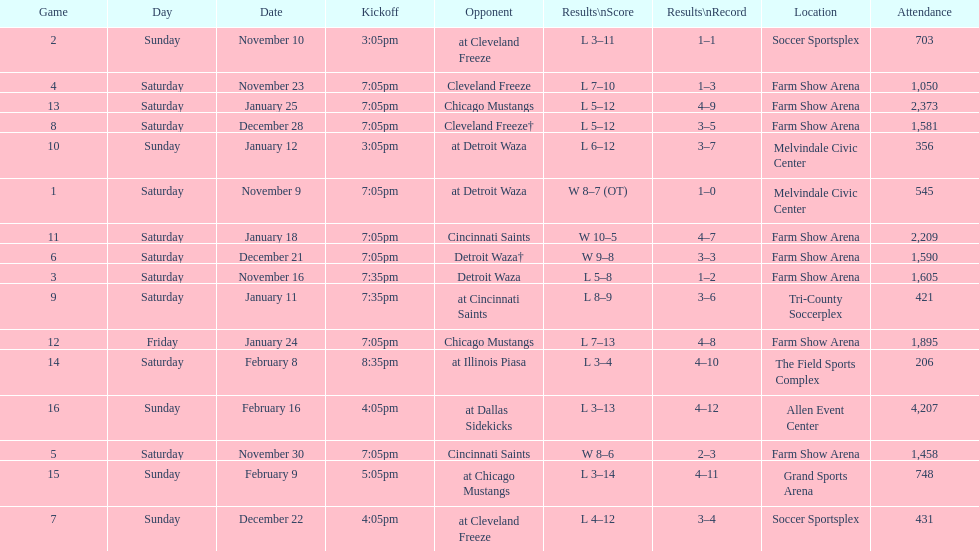I'm looking to parse the entire table for insights. Could you assist me with that? {'header': ['Game', 'Day', 'Date', 'Kickoff', 'Opponent', 'Results\\nScore', 'Results\\nRecord', 'Location', 'Attendance'], 'rows': [['2', 'Sunday', 'November 10', '3:05pm', 'at Cleveland Freeze', 'L 3–11', '1–1', 'Soccer Sportsplex', '703'], ['4', 'Saturday', 'November 23', '7:05pm', 'Cleveland Freeze', 'L 7–10', '1–3', 'Farm Show Arena', '1,050'], ['13', 'Saturday', 'January 25', '7:05pm', 'Chicago Mustangs', 'L 5–12', '4–9', 'Farm Show Arena', '2,373'], ['8', 'Saturday', 'December 28', '7:05pm', 'Cleveland Freeze†', 'L 5–12', '3–5', 'Farm Show Arena', '1,581'], ['10', 'Sunday', 'January 12', '3:05pm', 'at Detroit Waza', 'L 6–12', '3–7', 'Melvindale Civic Center', '356'], ['1', 'Saturday', 'November 9', '7:05pm', 'at Detroit Waza', 'W 8–7 (OT)', '1–0', 'Melvindale Civic Center', '545'], ['11', 'Saturday', 'January 18', '7:05pm', 'Cincinnati Saints', 'W 10–5', '4–7', 'Farm Show Arena', '2,209'], ['6', 'Saturday', 'December 21', '7:05pm', 'Detroit Waza†', 'W 9–8', '3–3', 'Farm Show Arena', '1,590'], ['3', 'Saturday', 'November 16', '7:35pm', 'Detroit Waza', 'L 5–8', '1–2', 'Farm Show Arena', '1,605'], ['9', 'Saturday', 'January 11', '7:35pm', 'at Cincinnati Saints', 'L 8–9', '3–6', 'Tri-County Soccerplex', '421'], ['12', 'Friday', 'January 24', '7:05pm', 'Chicago Mustangs', 'L 7–13', '4–8', 'Farm Show Arena', '1,895'], ['14', 'Saturday', 'February 8', '8:35pm', 'at Illinois Piasa', 'L 3–4', '4–10', 'The Field Sports Complex', '206'], ['16', 'Sunday', 'February 16', '4:05pm', 'at Dallas Sidekicks', 'L 3–13', '4–12', 'Allen Event Center', '4,207'], ['5', 'Saturday', 'November 30', '7:05pm', 'Cincinnati Saints', 'W 8–6', '2–3', 'Farm Show Arena', '1,458'], ['15', 'Sunday', 'February 9', '5:05pm', 'at Chicago Mustangs', 'L 3–14', '4–11', 'Grand Sports Arena', '748'], ['7', 'Sunday', 'December 22', '4:05pm', 'at Cleveland Freeze', 'L 4–12', '3–4', 'Soccer Sportsplex', '431']]} What was the location before tri-county soccerplex? Farm Show Arena. 